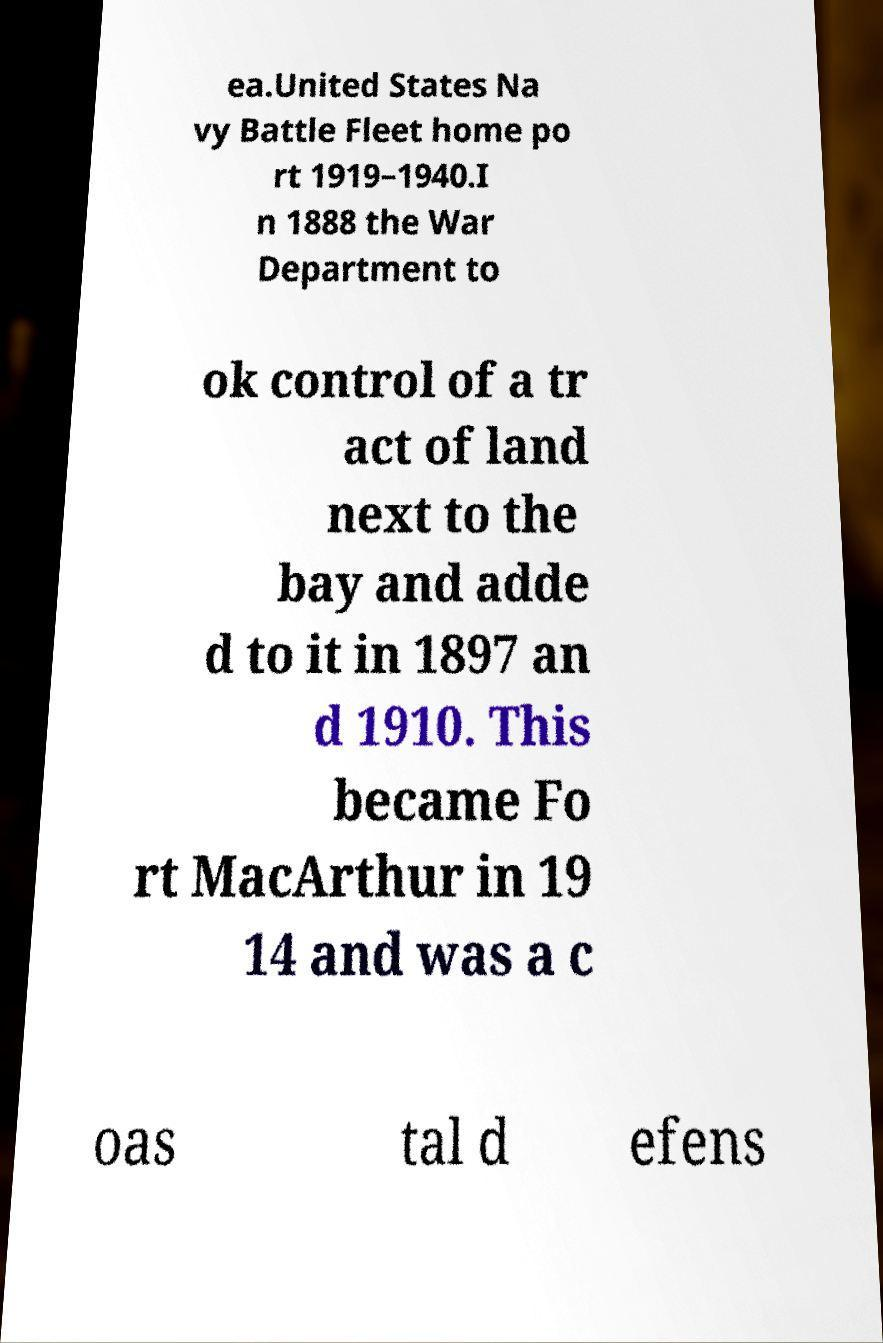Could you assist in decoding the text presented in this image and type it out clearly? ea.United States Na vy Battle Fleet home po rt 1919–1940.I n 1888 the War Department to ok control of a tr act of land next to the bay and adde d to it in 1897 an d 1910. This became Fo rt MacArthur in 19 14 and was a c oas tal d efens 